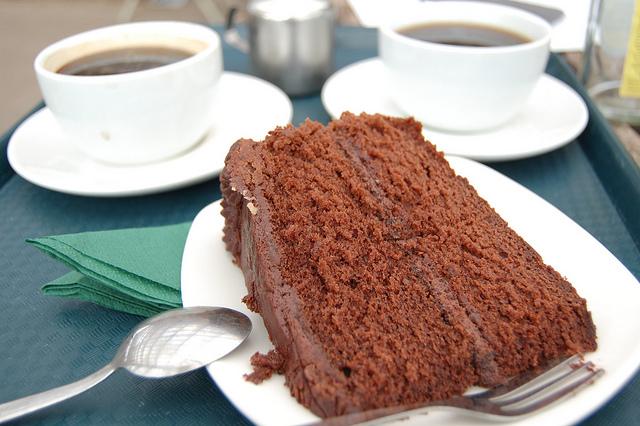Is the coffee straight black?
Write a very short answer. Yes. What color is the napkin?
Give a very brief answer. Green. How many cups are there?
Write a very short answer. 2. 